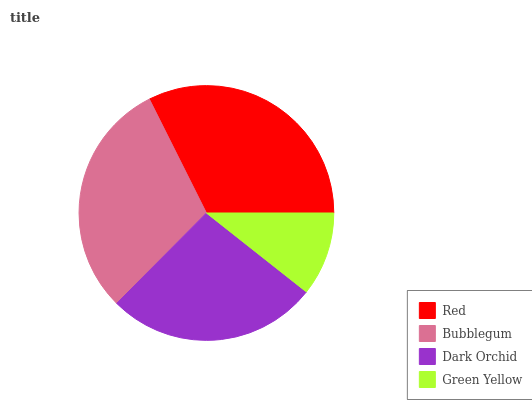Is Green Yellow the minimum?
Answer yes or no. Yes. Is Red the maximum?
Answer yes or no. Yes. Is Bubblegum the minimum?
Answer yes or no. No. Is Bubblegum the maximum?
Answer yes or no. No. Is Red greater than Bubblegum?
Answer yes or no. Yes. Is Bubblegum less than Red?
Answer yes or no. Yes. Is Bubblegum greater than Red?
Answer yes or no. No. Is Red less than Bubblegum?
Answer yes or no. No. Is Bubblegum the high median?
Answer yes or no. Yes. Is Dark Orchid the low median?
Answer yes or no. Yes. Is Red the high median?
Answer yes or no. No. Is Bubblegum the low median?
Answer yes or no. No. 